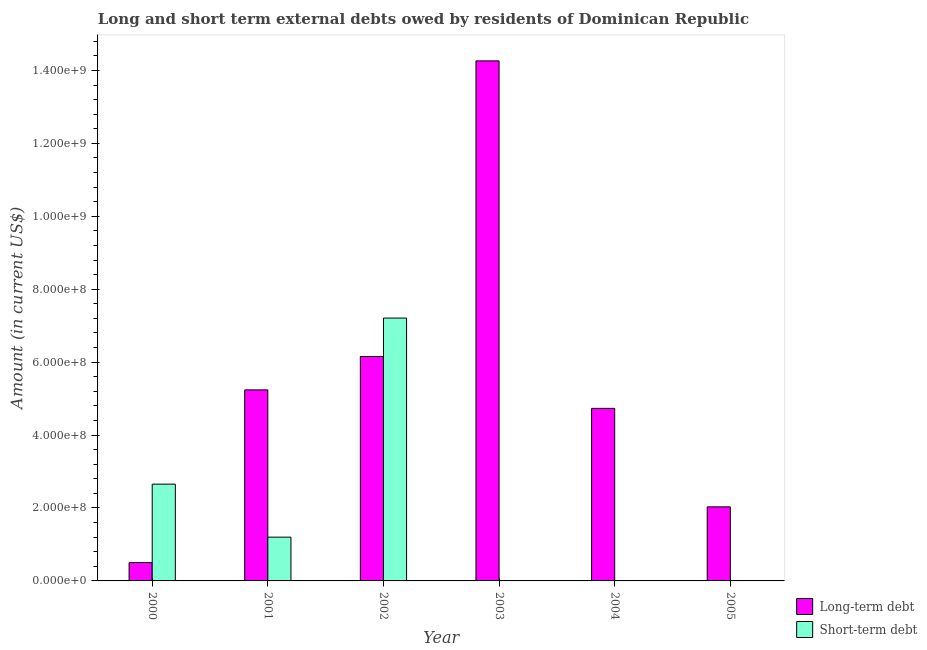How many different coloured bars are there?
Your answer should be compact. 2. Are the number of bars per tick equal to the number of legend labels?
Offer a terse response. No. Are the number of bars on each tick of the X-axis equal?
Your answer should be very brief. No. What is the long-term debts owed by residents in 2003?
Offer a terse response. 1.43e+09. Across all years, what is the maximum short-term debts owed by residents?
Make the answer very short. 7.21e+08. Across all years, what is the minimum short-term debts owed by residents?
Keep it short and to the point. 0. In which year was the short-term debts owed by residents maximum?
Your response must be concise. 2002. What is the total short-term debts owed by residents in the graph?
Offer a very short reply. 1.11e+09. What is the difference between the long-term debts owed by residents in 2002 and that in 2005?
Offer a very short reply. 4.12e+08. What is the difference between the short-term debts owed by residents in 2002 and the long-term debts owed by residents in 2004?
Your answer should be compact. 7.21e+08. What is the average short-term debts owed by residents per year?
Offer a terse response. 1.84e+08. In the year 2001, what is the difference between the short-term debts owed by residents and long-term debts owed by residents?
Your answer should be very brief. 0. In how many years, is the short-term debts owed by residents greater than 80000000 US$?
Your response must be concise. 3. What is the ratio of the long-term debts owed by residents in 2004 to that in 2005?
Make the answer very short. 2.33. What is the difference between the highest and the second highest long-term debts owed by residents?
Offer a very short reply. 8.11e+08. What is the difference between the highest and the lowest short-term debts owed by residents?
Ensure brevity in your answer.  7.21e+08. In how many years, is the long-term debts owed by residents greater than the average long-term debts owed by residents taken over all years?
Give a very brief answer. 2. Is the sum of the long-term debts owed by residents in 2001 and 2003 greater than the maximum short-term debts owed by residents across all years?
Keep it short and to the point. Yes. Are the values on the major ticks of Y-axis written in scientific E-notation?
Your answer should be very brief. Yes. Where does the legend appear in the graph?
Your response must be concise. Bottom right. How many legend labels are there?
Ensure brevity in your answer.  2. How are the legend labels stacked?
Your answer should be very brief. Vertical. What is the title of the graph?
Provide a short and direct response. Long and short term external debts owed by residents of Dominican Republic. Does "constant 2005 US$" appear as one of the legend labels in the graph?
Offer a very short reply. No. What is the label or title of the X-axis?
Provide a succinct answer. Year. What is the Amount (in current US$) of Long-term debt in 2000?
Keep it short and to the point. 5.03e+07. What is the Amount (in current US$) of Short-term debt in 2000?
Your answer should be very brief. 2.65e+08. What is the Amount (in current US$) of Long-term debt in 2001?
Ensure brevity in your answer.  5.24e+08. What is the Amount (in current US$) of Short-term debt in 2001?
Offer a terse response. 1.20e+08. What is the Amount (in current US$) of Long-term debt in 2002?
Your answer should be very brief. 6.15e+08. What is the Amount (in current US$) of Short-term debt in 2002?
Offer a terse response. 7.21e+08. What is the Amount (in current US$) of Long-term debt in 2003?
Provide a succinct answer. 1.43e+09. What is the Amount (in current US$) in Long-term debt in 2004?
Provide a short and direct response. 4.73e+08. What is the Amount (in current US$) of Short-term debt in 2004?
Provide a succinct answer. 0. What is the Amount (in current US$) in Long-term debt in 2005?
Offer a very short reply. 2.03e+08. Across all years, what is the maximum Amount (in current US$) of Long-term debt?
Make the answer very short. 1.43e+09. Across all years, what is the maximum Amount (in current US$) of Short-term debt?
Provide a short and direct response. 7.21e+08. Across all years, what is the minimum Amount (in current US$) of Long-term debt?
Your answer should be very brief. 5.03e+07. What is the total Amount (in current US$) of Long-term debt in the graph?
Your answer should be very brief. 3.29e+09. What is the total Amount (in current US$) in Short-term debt in the graph?
Offer a very short reply. 1.11e+09. What is the difference between the Amount (in current US$) in Long-term debt in 2000 and that in 2001?
Ensure brevity in your answer.  -4.74e+08. What is the difference between the Amount (in current US$) in Short-term debt in 2000 and that in 2001?
Offer a very short reply. 1.45e+08. What is the difference between the Amount (in current US$) of Long-term debt in 2000 and that in 2002?
Your response must be concise. -5.65e+08. What is the difference between the Amount (in current US$) in Short-term debt in 2000 and that in 2002?
Offer a very short reply. -4.55e+08. What is the difference between the Amount (in current US$) of Long-term debt in 2000 and that in 2003?
Make the answer very short. -1.38e+09. What is the difference between the Amount (in current US$) of Long-term debt in 2000 and that in 2004?
Offer a very short reply. -4.23e+08. What is the difference between the Amount (in current US$) of Long-term debt in 2000 and that in 2005?
Ensure brevity in your answer.  -1.53e+08. What is the difference between the Amount (in current US$) of Long-term debt in 2001 and that in 2002?
Provide a short and direct response. -9.15e+07. What is the difference between the Amount (in current US$) of Short-term debt in 2001 and that in 2002?
Give a very brief answer. -6.01e+08. What is the difference between the Amount (in current US$) of Long-term debt in 2001 and that in 2003?
Provide a short and direct response. -9.02e+08. What is the difference between the Amount (in current US$) in Long-term debt in 2001 and that in 2004?
Make the answer very short. 5.07e+07. What is the difference between the Amount (in current US$) of Long-term debt in 2001 and that in 2005?
Your answer should be very brief. 3.21e+08. What is the difference between the Amount (in current US$) in Long-term debt in 2002 and that in 2003?
Your answer should be compact. -8.11e+08. What is the difference between the Amount (in current US$) in Long-term debt in 2002 and that in 2004?
Provide a short and direct response. 1.42e+08. What is the difference between the Amount (in current US$) in Long-term debt in 2002 and that in 2005?
Your answer should be very brief. 4.12e+08. What is the difference between the Amount (in current US$) of Long-term debt in 2003 and that in 2004?
Your response must be concise. 9.53e+08. What is the difference between the Amount (in current US$) of Long-term debt in 2003 and that in 2005?
Give a very brief answer. 1.22e+09. What is the difference between the Amount (in current US$) of Long-term debt in 2004 and that in 2005?
Give a very brief answer. 2.70e+08. What is the difference between the Amount (in current US$) in Long-term debt in 2000 and the Amount (in current US$) in Short-term debt in 2001?
Give a very brief answer. -6.97e+07. What is the difference between the Amount (in current US$) of Long-term debt in 2000 and the Amount (in current US$) of Short-term debt in 2002?
Your answer should be compact. -6.71e+08. What is the difference between the Amount (in current US$) of Long-term debt in 2001 and the Amount (in current US$) of Short-term debt in 2002?
Offer a very short reply. -1.97e+08. What is the average Amount (in current US$) in Long-term debt per year?
Give a very brief answer. 5.49e+08. What is the average Amount (in current US$) of Short-term debt per year?
Provide a succinct answer. 1.84e+08. In the year 2000, what is the difference between the Amount (in current US$) in Long-term debt and Amount (in current US$) in Short-term debt?
Keep it short and to the point. -2.15e+08. In the year 2001, what is the difference between the Amount (in current US$) in Long-term debt and Amount (in current US$) in Short-term debt?
Give a very brief answer. 4.04e+08. In the year 2002, what is the difference between the Amount (in current US$) of Long-term debt and Amount (in current US$) of Short-term debt?
Ensure brevity in your answer.  -1.05e+08. What is the ratio of the Amount (in current US$) in Long-term debt in 2000 to that in 2001?
Your answer should be very brief. 0.1. What is the ratio of the Amount (in current US$) in Short-term debt in 2000 to that in 2001?
Offer a very short reply. 2.21. What is the ratio of the Amount (in current US$) of Long-term debt in 2000 to that in 2002?
Your answer should be very brief. 0.08. What is the ratio of the Amount (in current US$) of Short-term debt in 2000 to that in 2002?
Make the answer very short. 0.37. What is the ratio of the Amount (in current US$) in Long-term debt in 2000 to that in 2003?
Give a very brief answer. 0.04. What is the ratio of the Amount (in current US$) in Long-term debt in 2000 to that in 2004?
Ensure brevity in your answer.  0.11. What is the ratio of the Amount (in current US$) in Long-term debt in 2000 to that in 2005?
Offer a very short reply. 0.25. What is the ratio of the Amount (in current US$) of Long-term debt in 2001 to that in 2002?
Make the answer very short. 0.85. What is the ratio of the Amount (in current US$) of Short-term debt in 2001 to that in 2002?
Provide a succinct answer. 0.17. What is the ratio of the Amount (in current US$) in Long-term debt in 2001 to that in 2003?
Provide a succinct answer. 0.37. What is the ratio of the Amount (in current US$) of Long-term debt in 2001 to that in 2004?
Your answer should be very brief. 1.11. What is the ratio of the Amount (in current US$) of Long-term debt in 2001 to that in 2005?
Provide a short and direct response. 2.58. What is the ratio of the Amount (in current US$) of Long-term debt in 2002 to that in 2003?
Your answer should be compact. 0.43. What is the ratio of the Amount (in current US$) in Long-term debt in 2002 to that in 2004?
Ensure brevity in your answer.  1.3. What is the ratio of the Amount (in current US$) in Long-term debt in 2002 to that in 2005?
Ensure brevity in your answer.  3.03. What is the ratio of the Amount (in current US$) in Long-term debt in 2003 to that in 2004?
Offer a very short reply. 3.01. What is the ratio of the Amount (in current US$) of Long-term debt in 2003 to that in 2005?
Your response must be concise. 7.02. What is the ratio of the Amount (in current US$) of Long-term debt in 2004 to that in 2005?
Offer a very short reply. 2.33. What is the difference between the highest and the second highest Amount (in current US$) in Long-term debt?
Give a very brief answer. 8.11e+08. What is the difference between the highest and the second highest Amount (in current US$) in Short-term debt?
Make the answer very short. 4.55e+08. What is the difference between the highest and the lowest Amount (in current US$) of Long-term debt?
Your answer should be very brief. 1.38e+09. What is the difference between the highest and the lowest Amount (in current US$) in Short-term debt?
Keep it short and to the point. 7.21e+08. 